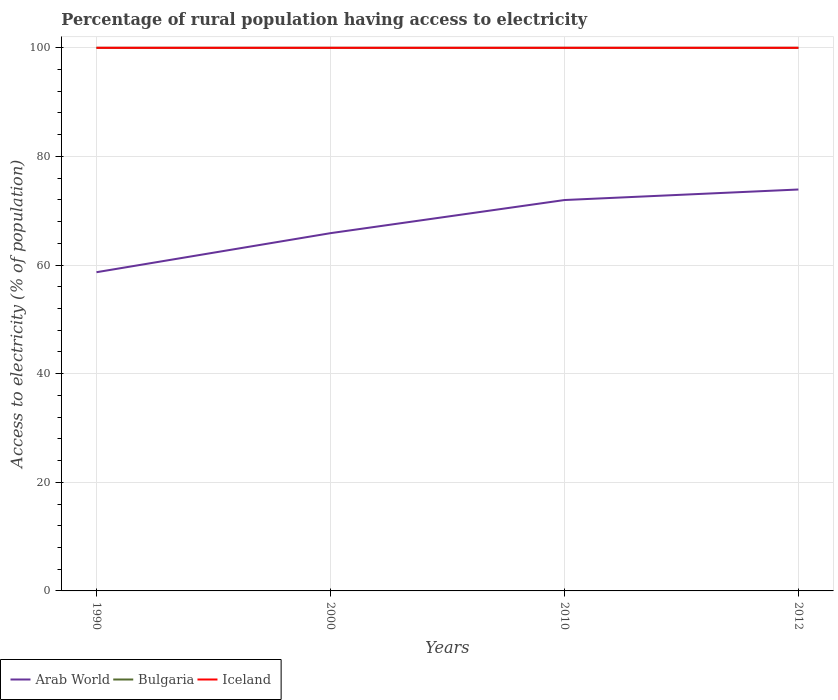How many different coloured lines are there?
Ensure brevity in your answer.  3. Across all years, what is the maximum percentage of rural population having access to electricity in Arab World?
Your answer should be very brief. 58.68. In which year was the percentage of rural population having access to electricity in Iceland maximum?
Provide a short and direct response. 1990. What is the total percentage of rural population having access to electricity in Arab World in the graph?
Ensure brevity in your answer.  -7.19. Is the percentage of rural population having access to electricity in Arab World strictly greater than the percentage of rural population having access to electricity in Bulgaria over the years?
Give a very brief answer. Yes. How many lines are there?
Your response must be concise. 3. Are the values on the major ticks of Y-axis written in scientific E-notation?
Your answer should be compact. No. Does the graph contain any zero values?
Your answer should be compact. No. What is the title of the graph?
Provide a short and direct response. Percentage of rural population having access to electricity. What is the label or title of the X-axis?
Provide a succinct answer. Years. What is the label or title of the Y-axis?
Give a very brief answer. Access to electricity (% of population). What is the Access to electricity (% of population) of Arab World in 1990?
Give a very brief answer. 58.68. What is the Access to electricity (% of population) in Arab World in 2000?
Your answer should be very brief. 65.87. What is the Access to electricity (% of population) of Arab World in 2010?
Provide a short and direct response. 71.97. What is the Access to electricity (% of population) in Bulgaria in 2010?
Your response must be concise. 100. What is the Access to electricity (% of population) in Iceland in 2010?
Keep it short and to the point. 100. What is the Access to electricity (% of population) in Arab World in 2012?
Keep it short and to the point. 73.91. Across all years, what is the maximum Access to electricity (% of population) of Arab World?
Keep it short and to the point. 73.91. Across all years, what is the maximum Access to electricity (% of population) in Bulgaria?
Provide a succinct answer. 100. Across all years, what is the minimum Access to electricity (% of population) of Arab World?
Ensure brevity in your answer.  58.68. Across all years, what is the minimum Access to electricity (% of population) of Bulgaria?
Keep it short and to the point. 100. What is the total Access to electricity (% of population) in Arab World in the graph?
Your answer should be very brief. 270.43. What is the difference between the Access to electricity (% of population) in Arab World in 1990 and that in 2000?
Offer a very short reply. -7.19. What is the difference between the Access to electricity (% of population) of Bulgaria in 1990 and that in 2000?
Ensure brevity in your answer.  0. What is the difference between the Access to electricity (% of population) of Iceland in 1990 and that in 2000?
Provide a short and direct response. 0. What is the difference between the Access to electricity (% of population) of Arab World in 1990 and that in 2010?
Offer a terse response. -13.29. What is the difference between the Access to electricity (% of population) of Bulgaria in 1990 and that in 2010?
Give a very brief answer. 0. What is the difference between the Access to electricity (% of population) in Arab World in 1990 and that in 2012?
Your response must be concise. -15.23. What is the difference between the Access to electricity (% of population) of Arab World in 2000 and that in 2010?
Make the answer very short. -6.1. What is the difference between the Access to electricity (% of population) in Arab World in 2000 and that in 2012?
Make the answer very short. -8.04. What is the difference between the Access to electricity (% of population) of Iceland in 2000 and that in 2012?
Your answer should be very brief. 0. What is the difference between the Access to electricity (% of population) in Arab World in 2010 and that in 2012?
Offer a terse response. -1.94. What is the difference between the Access to electricity (% of population) of Bulgaria in 2010 and that in 2012?
Keep it short and to the point. 0. What is the difference between the Access to electricity (% of population) of Arab World in 1990 and the Access to electricity (% of population) of Bulgaria in 2000?
Keep it short and to the point. -41.32. What is the difference between the Access to electricity (% of population) of Arab World in 1990 and the Access to electricity (% of population) of Iceland in 2000?
Offer a very short reply. -41.32. What is the difference between the Access to electricity (% of population) of Bulgaria in 1990 and the Access to electricity (% of population) of Iceland in 2000?
Give a very brief answer. 0. What is the difference between the Access to electricity (% of population) in Arab World in 1990 and the Access to electricity (% of population) in Bulgaria in 2010?
Give a very brief answer. -41.32. What is the difference between the Access to electricity (% of population) in Arab World in 1990 and the Access to electricity (% of population) in Iceland in 2010?
Your answer should be compact. -41.32. What is the difference between the Access to electricity (% of population) in Bulgaria in 1990 and the Access to electricity (% of population) in Iceland in 2010?
Your answer should be very brief. 0. What is the difference between the Access to electricity (% of population) of Arab World in 1990 and the Access to electricity (% of population) of Bulgaria in 2012?
Provide a succinct answer. -41.32. What is the difference between the Access to electricity (% of population) of Arab World in 1990 and the Access to electricity (% of population) of Iceland in 2012?
Your answer should be compact. -41.32. What is the difference between the Access to electricity (% of population) of Arab World in 2000 and the Access to electricity (% of population) of Bulgaria in 2010?
Make the answer very short. -34.13. What is the difference between the Access to electricity (% of population) of Arab World in 2000 and the Access to electricity (% of population) of Iceland in 2010?
Your answer should be compact. -34.13. What is the difference between the Access to electricity (% of population) of Arab World in 2000 and the Access to electricity (% of population) of Bulgaria in 2012?
Your answer should be compact. -34.13. What is the difference between the Access to electricity (% of population) in Arab World in 2000 and the Access to electricity (% of population) in Iceland in 2012?
Give a very brief answer. -34.13. What is the difference between the Access to electricity (% of population) in Arab World in 2010 and the Access to electricity (% of population) in Bulgaria in 2012?
Your answer should be very brief. -28.03. What is the difference between the Access to electricity (% of population) of Arab World in 2010 and the Access to electricity (% of population) of Iceland in 2012?
Keep it short and to the point. -28.03. What is the average Access to electricity (% of population) of Arab World per year?
Your response must be concise. 67.61. What is the average Access to electricity (% of population) in Bulgaria per year?
Your answer should be very brief. 100. In the year 1990, what is the difference between the Access to electricity (% of population) of Arab World and Access to electricity (% of population) of Bulgaria?
Your response must be concise. -41.32. In the year 1990, what is the difference between the Access to electricity (% of population) in Arab World and Access to electricity (% of population) in Iceland?
Your answer should be compact. -41.32. In the year 2000, what is the difference between the Access to electricity (% of population) in Arab World and Access to electricity (% of population) in Bulgaria?
Make the answer very short. -34.13. In the year 2000, what is the difference between the Access to electricity (% of population) in Arab World and Access to electricity (% of population) in Iceland?
Ensure brevity in your answer.  -34.13. In the year 2010, what is the difference between the Access to electricity (% of population) in Arab World and Access to electricity (% of population) in Bulgaria?
Make the answer very short. -28.03. In the year 2010, what is the difference between the Access to electricity (% of population) in Arab World and Access to electricity (% of population) in Iceland?
Offer a terse response. -28.03. In the year 2012, what is the difference between the Access to electricity (% of population) in Arab World and Access to electricity (% of population) in Bulgaria?
Provide a short and direct response. -26.09. In the year 2012, what is the difference between the Access to electricity (% of population) in Arab World and Access to electricity (% of population) in Iceland?
Your answer should be very brief. -26.09. What is the ratio of the Access to electricity (% of population) of Arab World in 1990 to that in 2000?
Provide a succinct answer. 0.89. What is the ratio of the Access to electricity (% of population) of Bulgaria in 1990 to that in 2000?
Ensure brevity in your answer.  1. What is the ratio of the Access to electricity (% of population) of Iceland in 1990 to that in 2000?
Keep it short and to the point. 1. What is the ratio of the Access to electricity (% of population) of Arab World in 1990 to that in 2010?
Make the answer very short. 0.82. What is the ratio of the Access to electricity (% of population) of Bulgaria in 1990 to that in 2010?
Offer a terse response. 1. What is the ratio of the Access to electricity (% of population) of Arab World in 1990 to that in 2012?
Your response must be concise. 0.79. What is the ratio of the Access to electricity (% of population) of Arab World in 2000 to that in 2010?
Ensure brevity in your answer.  0.92. What is the ratio of the Access to electricity (% of population) in Iceland in 2000 to that in 2010?
Your answer should be compact. 1. What is the ratio of the Access to electricity (% of population) of Arab World in 2000 to that in 2012?
Keep it short and to the point. 0.89. What is the ratio of the Access to electricity (% of population) in Bulgaria in 2000 to that in 2012?
Give a very brief answer. 1. What is the ratio of the Access to electricity (% of population) of Arab World in 2010 to that in 2012?
Your answer should be very brief. 0.97. What is the ratio of the Access to electricity (% of population) in Bulgaria in 2010 to that in 2012?
Keep it short and to the point. 1. What is the difference between the highest and the second highest Access to electricity (% of population) in Arab World?
Make the answer very short. 1.94. What is the difference between the highest and the second highest Access to electricity (% of population) of Bulgaria?
Make the answer very short. 0. What is the difference between the highest and the lowest Access to electricity (% of population) of Arab World?
Provide a succinct answer. 15.23. What is the difference between the highest and the lowest Access to electricity (% of population) of Iceland?
Make the answer very short. 0. 